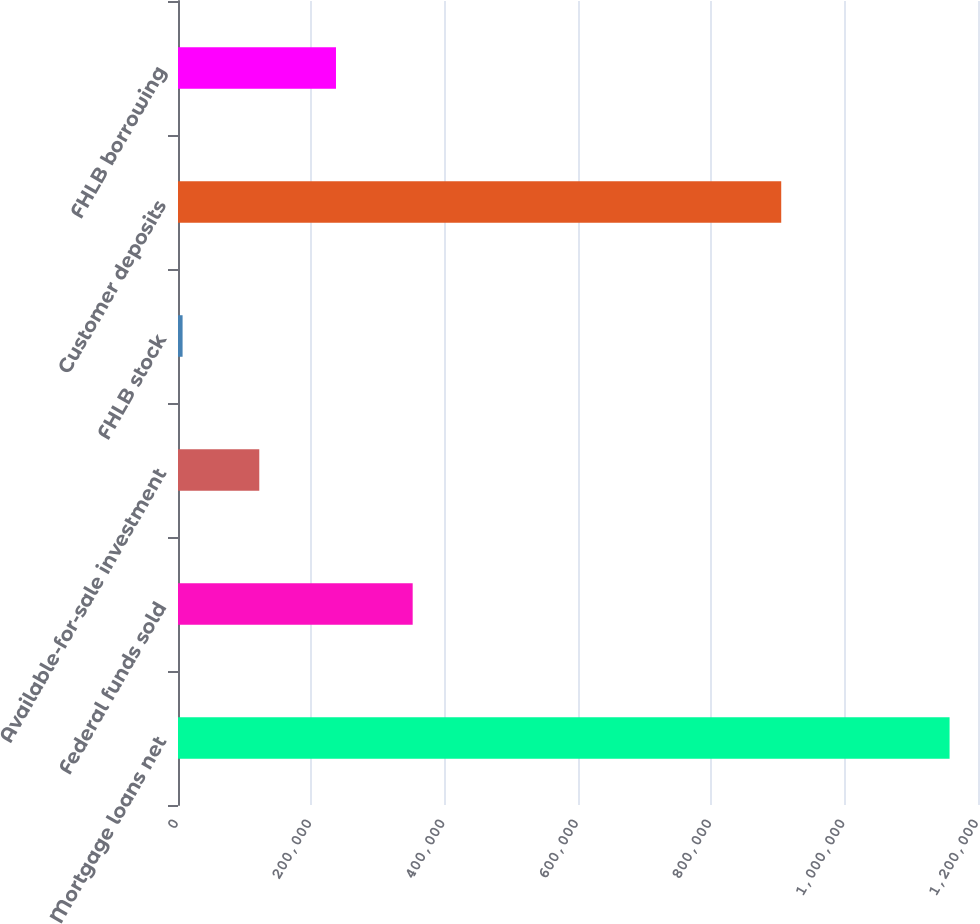Convert chart to OTSL. <chart><loc_0><loc_0><loc_500><loc_500><bar_chart><fcel>Mortgage loans net<fcel>Federal funds sold<fcel>Available-for-sale investment<fcel>FHLB stock<fcel>Customer deposits<fcel>FHLB borrowing<nl><fcel>1.15736e+06<fcel>352021<fcel>121924<fcel>6876<fcel>904836<fcel>236973<nl></chart> 